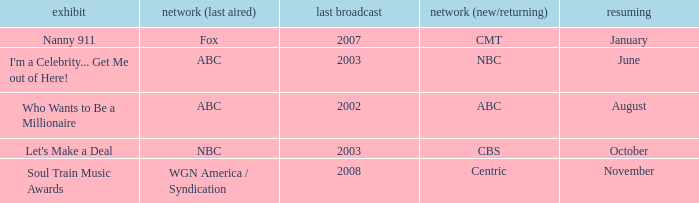When did a show last aired in 2002 return? August. 